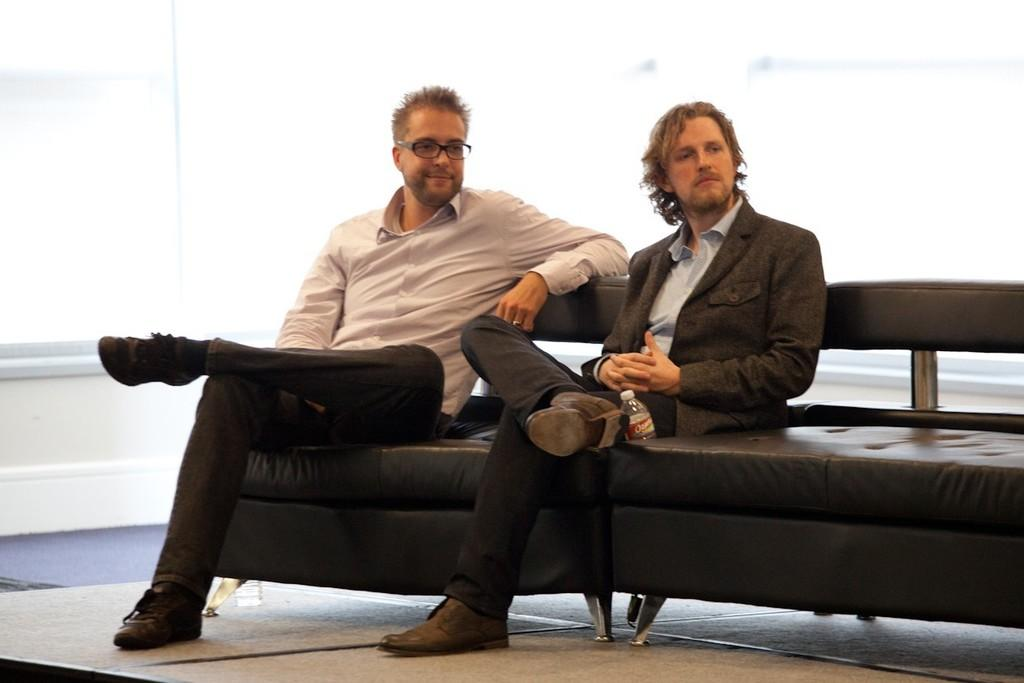How many people are in the image? There are two people in the image. What are the two people doing in the image? The two people are sitting on a sofa. Can you describe one of the people in the image? One of the people is wearing glasses (specs). What can be seen near the people in the image? There is a water bottle visible in the image. How many children are playing with a needle in the image? There are no children or needles present in the image. 